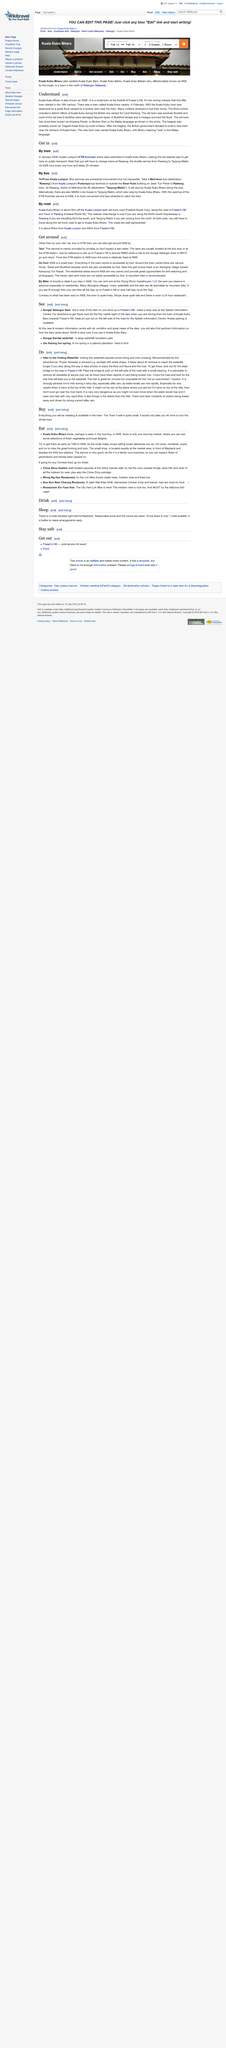Give some essential details in this illustration. It is expected to take approximately 45 minutes to reach the waterfall. At the Flying Rhino Guesthouse in KKB, bicycles can be rented for your convenience. The village of Kampumg Tun Razak is located near a golf course and is inhabited by Aborigines. It is recommended that individuals with an adventurous spirit embark on a hike to the chilling waterfall. Kuala Kubu Bharu is a town located in the north of Selangor, Malaysia. 